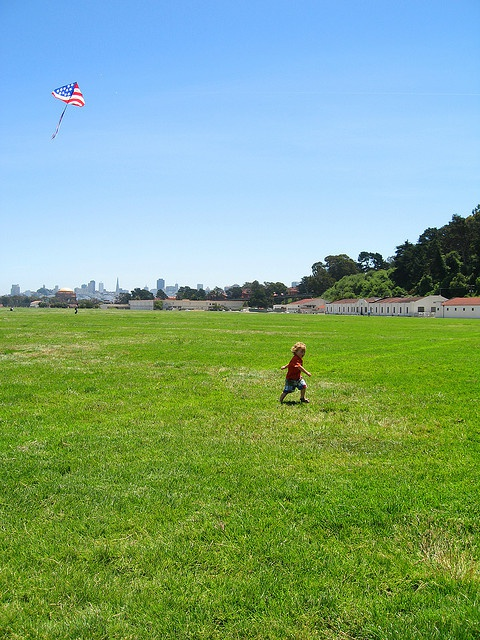Describe the objects in this image and their specific colors. I can see people in lightblue, black, maroon, and olive tones, kite in lightblue, white, and blue tones, people in lightblue, black, and gray tones, people in lightblue, black, gray, and green tones, and people in lightblue, gray, black, and darkgreen tones in this image. 